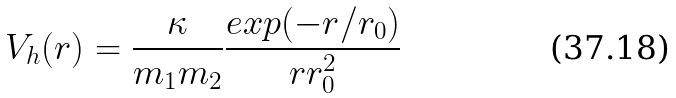<formula> <loc_0><loc_0><loc_500><loc_500>V _ { h } ( r ) = \frac { \kappa } { m _ { 1 } m _ { 2 } } \frac { e x p ( - r / r _ { 0 } ) } { r r _ { 0 } ^ { 2 } }</formula> 